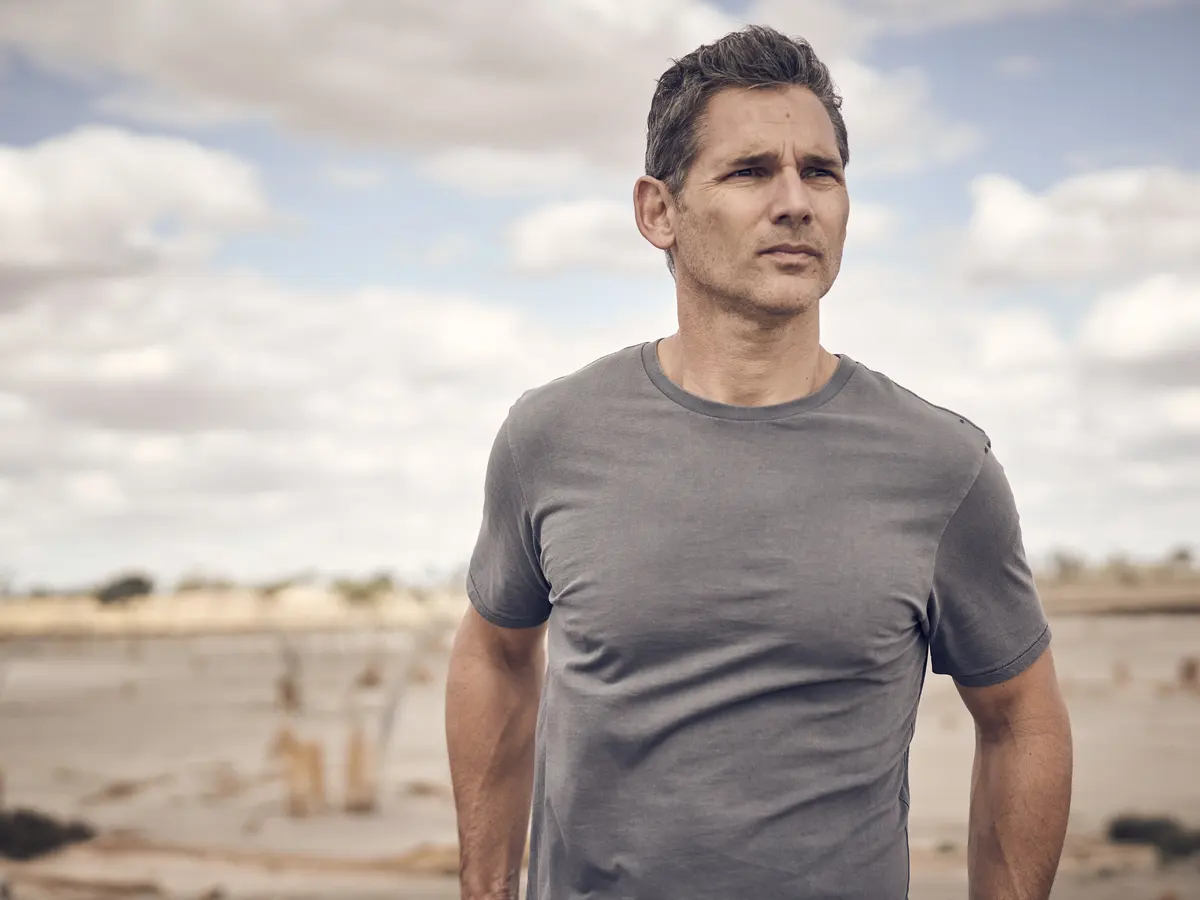If this beach were to have a soundtrack, what kind of music would be playing and why? If this beach were to have a soundtrack, it would likely feature soft, melancholic instrumental music or a gentle acoustic guitar melody. Such music would complement the contemplative and serene atmosphere of the scene, enhancing the introspective mood conveyed by the man's stance and the overcast sky. The music would ebb and flow like the waves, providing a soothing yet poignant backdrop to his thoughts. 